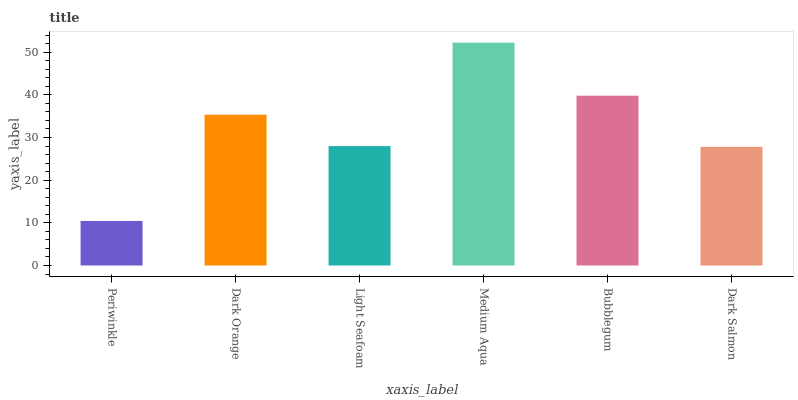Is Dark Orange the minimum?
Answer yes or no. No. Is Dark Orange the maximum?
Answer yes or no. No. Is Dark Orange greater than Periwinkle?
Answer yes or no. Yes. Is Periwinkle less than Dark Orange?
Answer yes or no. Yes. Is Periwinkle greater than Dark Orange?
Answer yes or no. No. Is Dark Orange less than Periwinkle?
Answer yes or no. No. Is Dark Orange the high median?
Answer yes or no. Yes. Is Light Seafoam the low median?
Answer yes or no. Yes. Is Light Seafoam the high median?
Answer yes or no. No. Is Bubblegum the low median?
Answer yes or no. No. 